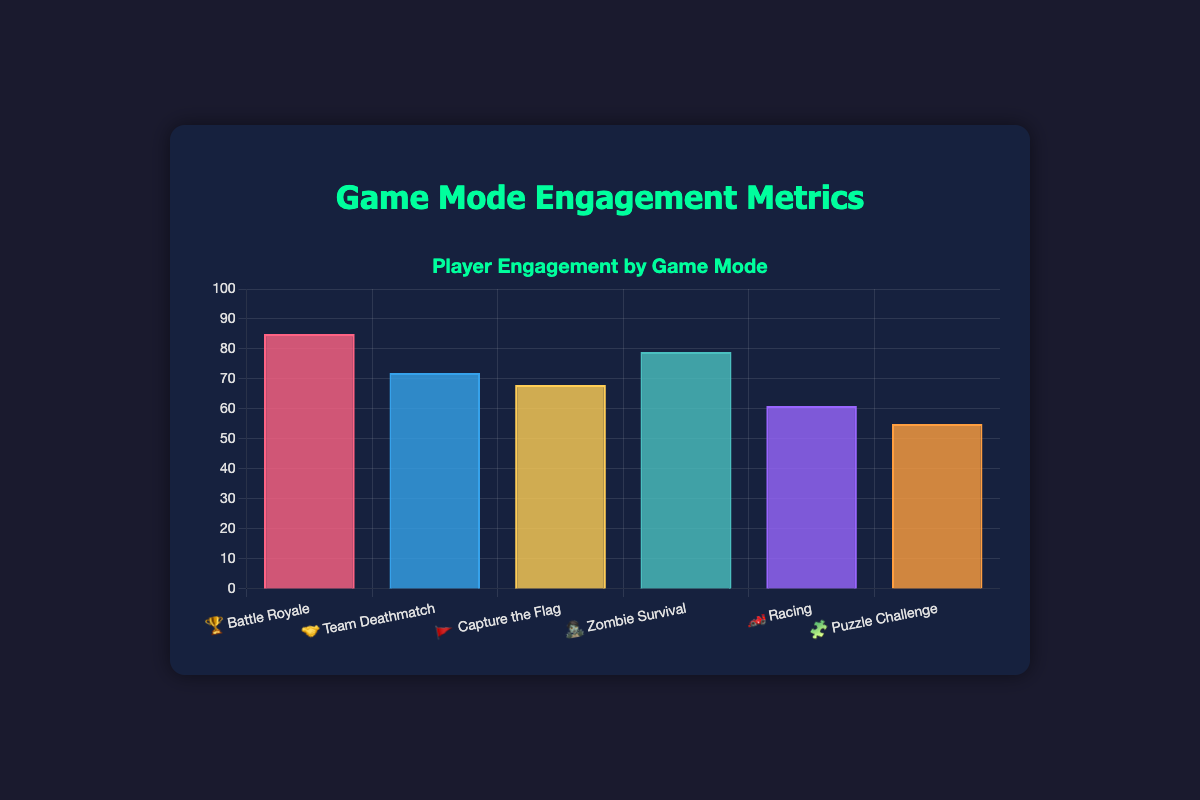What is the highest engagement score and which game mode does it belong to? The highest engagement score is represented by the tallest bar in the chart. The "Battle Royale" game mode has the highest engagement score of 85, associated with the emoji "🏆".
Answer: 85 (Battle Royale 🏆) Which game mode has the lowest engagement score and what is its value? The shortest bar represents the game mode with the lowest engagement score. "Puzzle Challenge" has the lowest engagement score of 55, associated with the emoji "🧩".
Answer: 55 (Puzzle Challenge 🧩) How many game modes have an engagement score greater than 70? To find the number of game modes with engagement scores greater than 70, count the bars above the 70-mark. "Battle Royale" (85), "Team Deathmatch" (72), and "Zombie Survival" (79) fit this criterion.
Answer: 3 What is the total sum of the engagement scores for all game modes? Add up the engagement scores for all 6 game modes: 85 + 72 + 68 + 79 + 61 + 55. The sum is 420.
Answer: 420 Which two game modes have the closest engagement scores and what are those scores? Comparing the engagement scores, "Team Deathmatch" (72) and "Capture the Flag" (68) have the closest scores with a difference of 4.
Answer: Team Deathmatch (72) and Capture the Flag (68) What is the average engagement score across all game modes? The average is calculated by summing all the scores and dividing by the number of game modes. (85 + 72 + 68 + 79 + 61 + 55) / 6 = 420 / 6 = 70.
Answer: 70 Which game mode with an engagement score less than 70 performs the best? From the game modes with scores less than 70, compare the scores: Capture the Flag (68), Racing (61), and Puzzle Challenge (55). "Capture the Flag" performs the best with an engagement score of 68.
Answer: Capture the Flag (68) What is the difference between the highest and the lowest engagement scores? Subtract the lowest score from the highest score. The highest engagement score is 85 (Battle Royale 🏆) and the lowest is 55 (Puzzle Challenge 🧩). The difference is 85 - 55 = 30.
Answer: 30 Between "Racing" and "Zombie Survival", which game mode has a higher engagement score and by how much? Compare the scores of "Racing" (61) and "Zombie Survival" (79). "Zombie Survival" has a higher engagement score. The difference is 79 - 61 = 18.
Answer: Zombie Survival by 18 